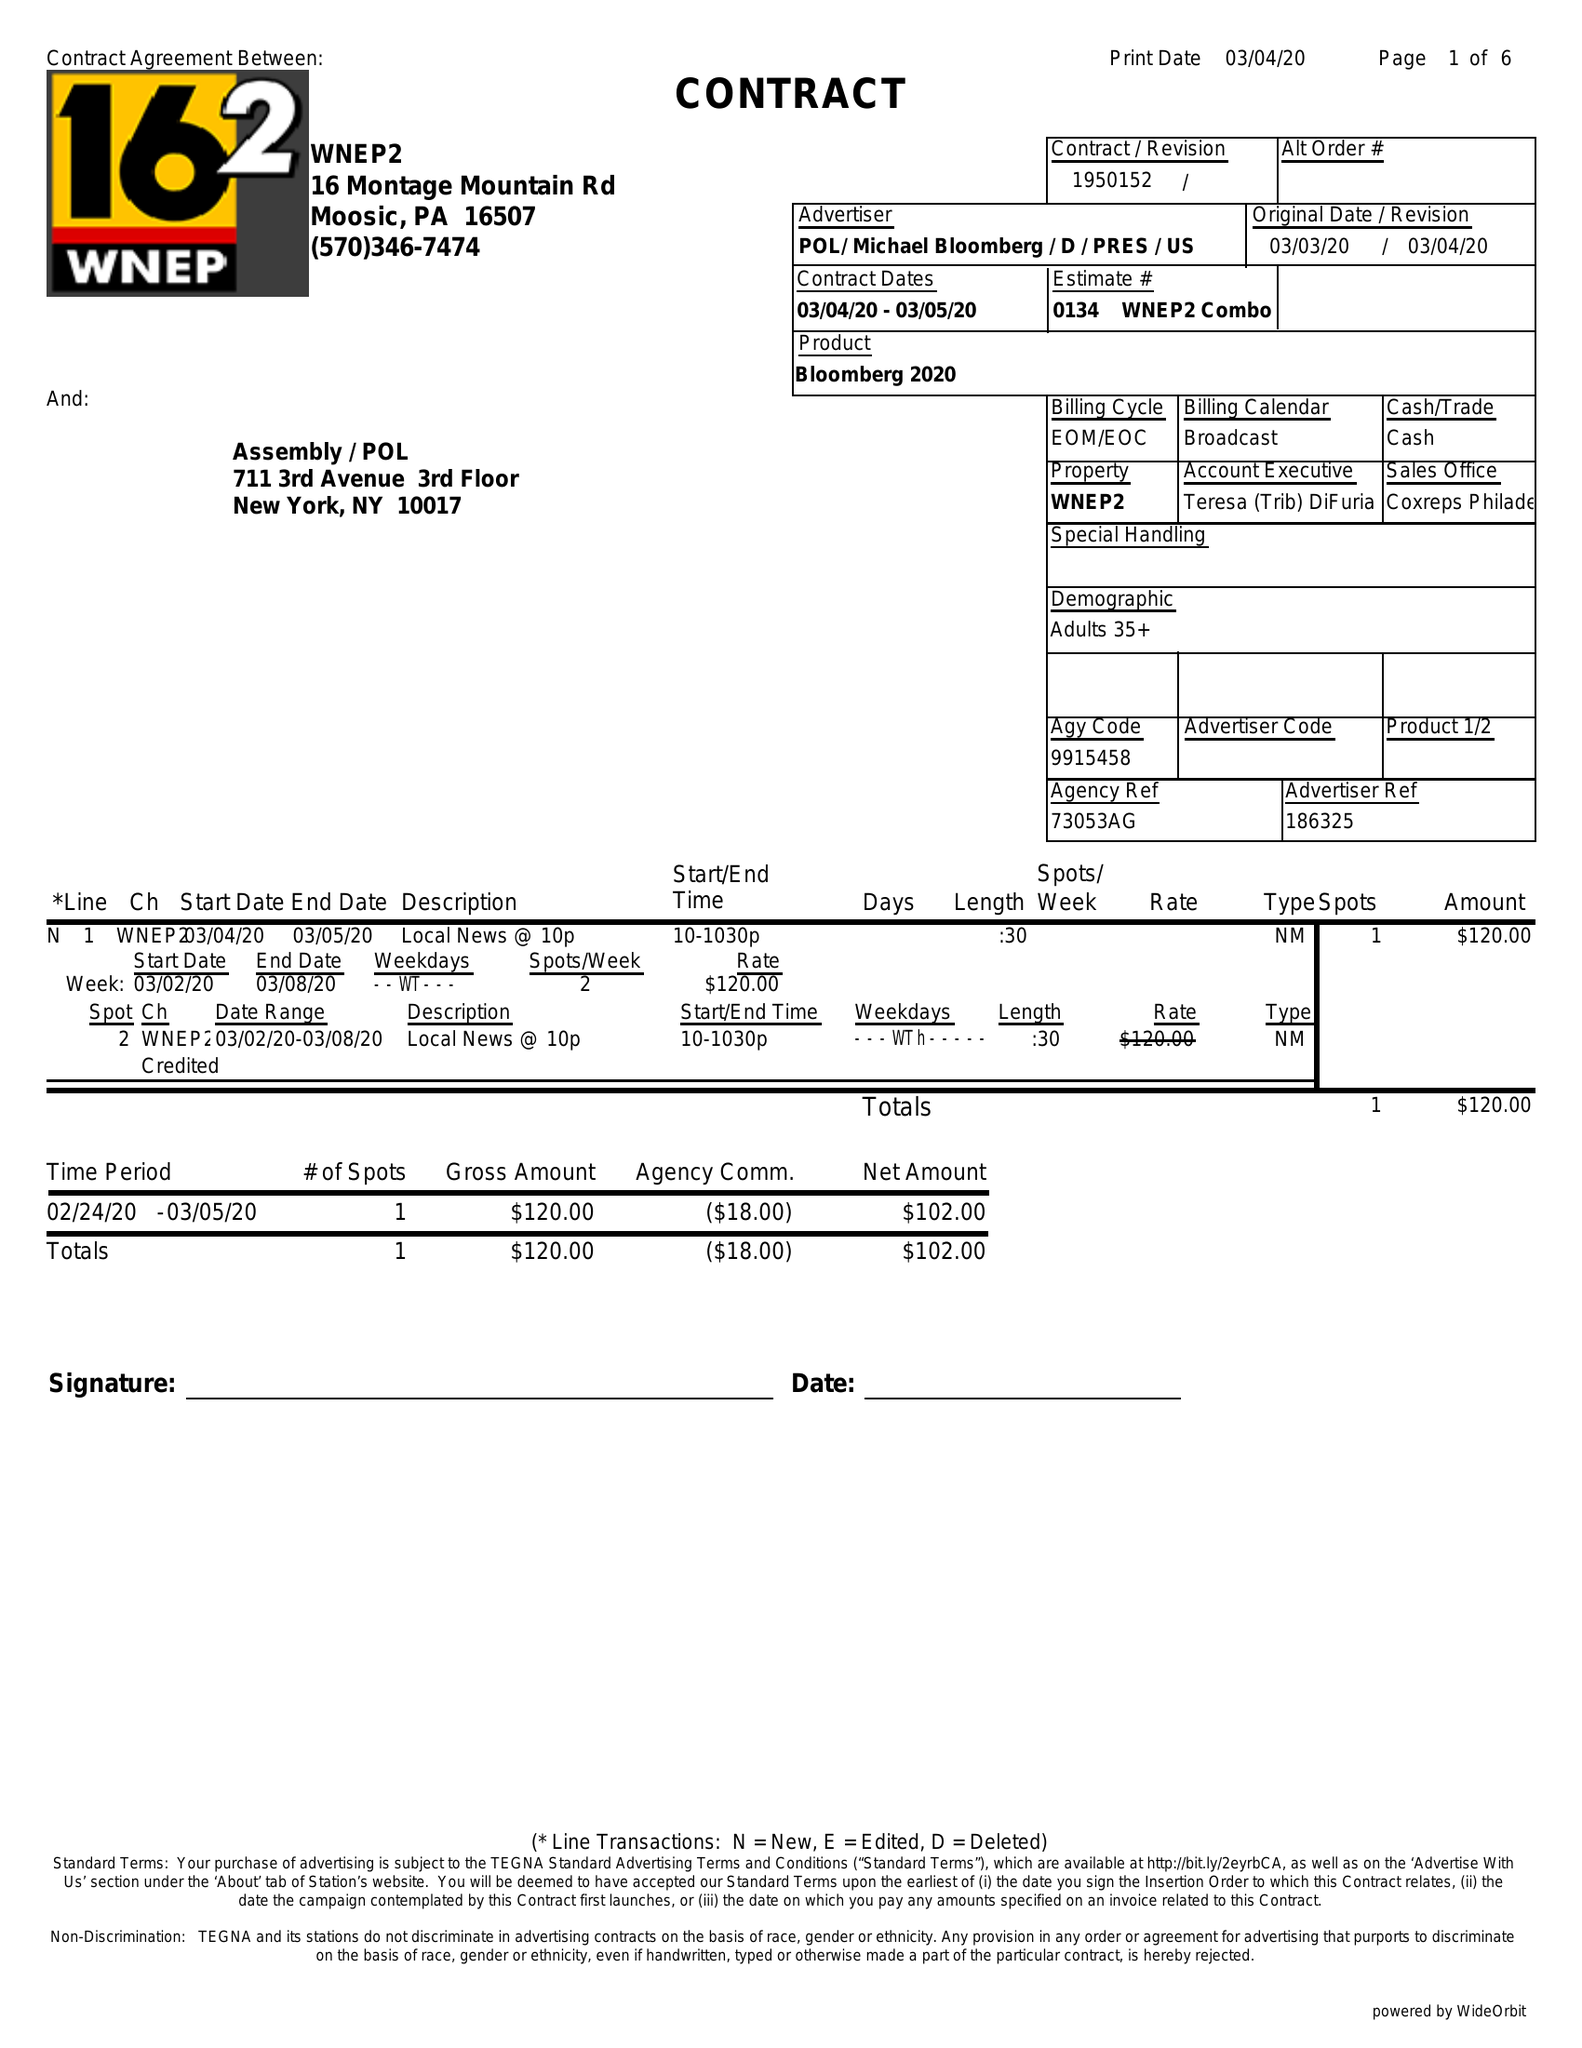What is the value for the gross_amount?
Answer the question using a single word or phrase. 120.00 